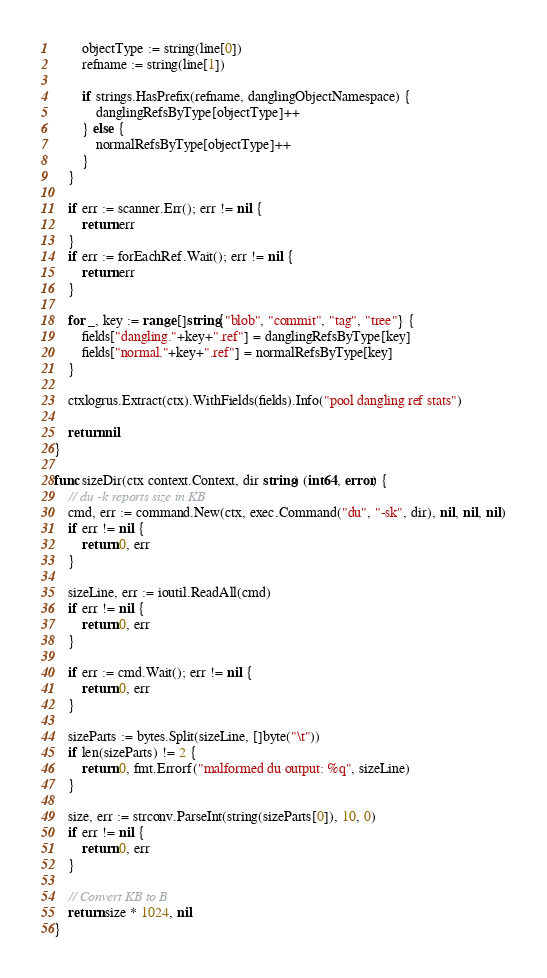Convert code to text. <code><loc_0><loc_0><loc_500><loc_500><_Go_>		objectType := string(line[0])
		refname := string(line[1])

		if strings.HasPrefix(refname, danglingObjectNamespace) {
			danglingRefsByType[objectType]++
		} else {
			normalRefsByType[objectType]++
		}
	}

	if err := scanner.Err(); err != nil {
		return err
	}
	if err := forEachRef.Wait(); err != nil {
		return err
	}

	for _, key := range []string{"blob", "commit", "tag", "tree"} {
		fields["dangling."+key+".ref"] = danglingRefsByType[key]
		fields["normal."+key+".ref"] = normalRefsByType[key]
	}

	ctxlogrus.Extract(ctx).WithFields(fields).Info("pool dangling ref stats")

	return nil
}

func sizeDir(ctx context.Context, dir string) (int64, error) {
	// du -k reports size in KB
	cmd, err := command.New(ctx, exec.Command("du", "-sk", dir), nil, nil, nil)
	if err != nil {
		return 0, err
	}

	sizeLine, err := ioutil.ReadAll(cmd)
	if err != nil {
		return 0, err
	}

	if err := cmd.Wait(); err != nil {
		return 0, err
	}

	sizeParts := bytes.Split(sizeLine, []byte("\t"))
	if len(sizeParts) != 2 {
		return 0, fmt.Errorf("malformed du output: %q", sizeLine)
	}

	size, err := strconv.ParseInt(string(sizeParts[0]), 10, 0)
	if err != nil {
		return 0, err
	}

	// Convert KB to B
	return size * 1024, nil
}
</code> 